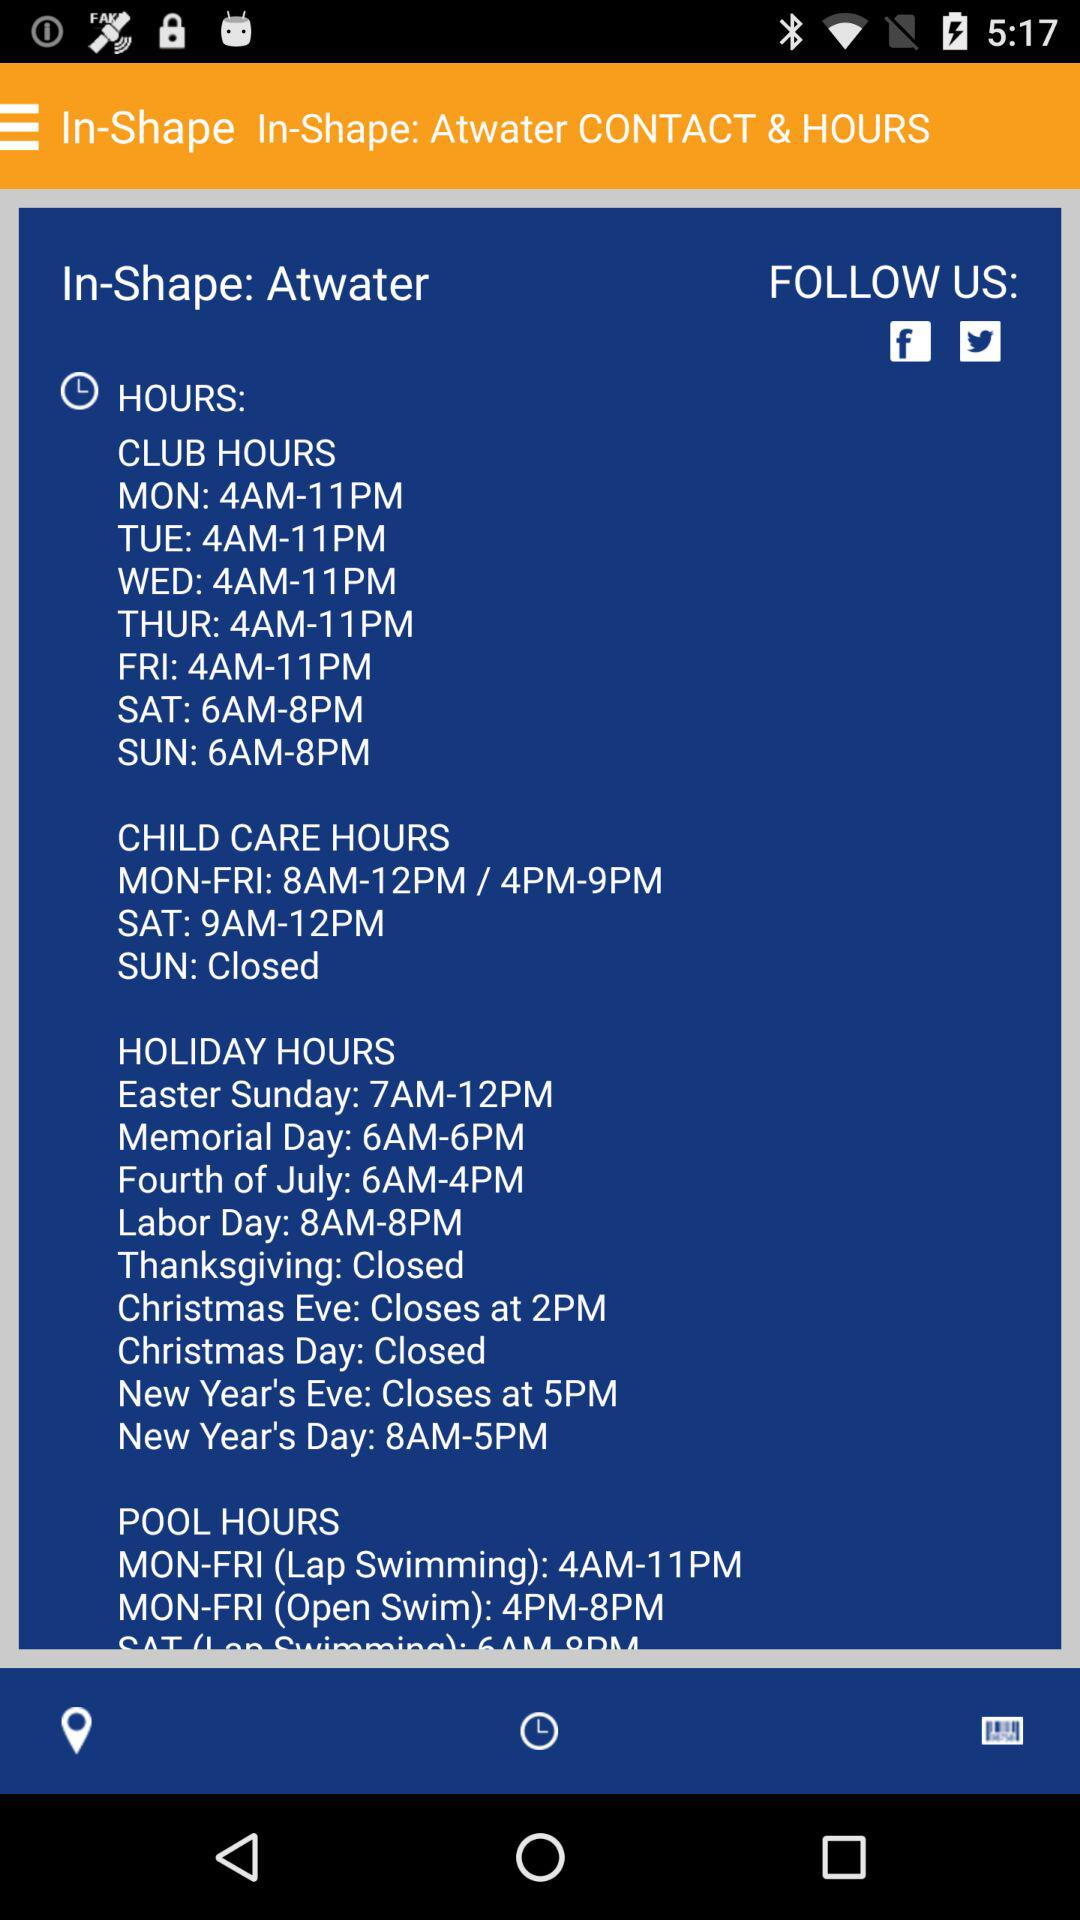When are the child care hours closed? The child care hours are closed on Sunday. 